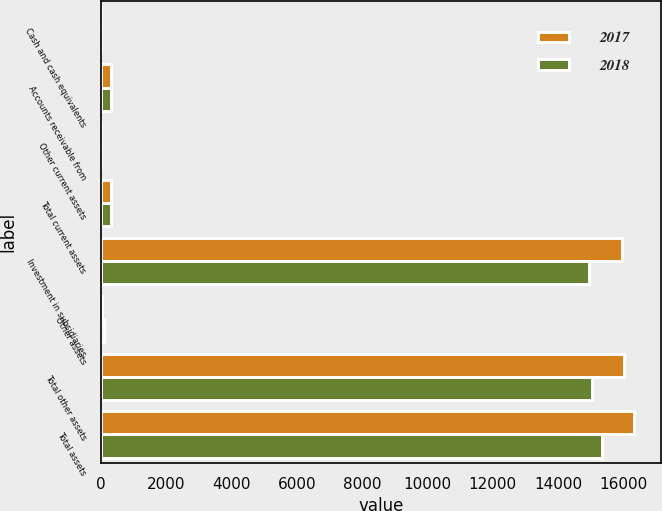<chart> <loc_0><loc_0><loc_500><loc_500><stacked_bar_chart><ecel><fcel>Cash and cash equivalents<fcel>Accounts receivable from<fcel>Other current assets<fcel>Total current assets<fcel>Investment in subsidiaries<fcel>Other assets<fcel>Total other assets<fcel>Total assets<nl><fcel>2017<fcel>1<fcel>309<fcel>1<fcel>311<fcel>15965<fcel>44<fcel>16009<fcel>16320<nl><fcel>2018<fcel>1<fcel>302<fcel>1<fcel>304<fcel>14932<fcel>103<fcel>15035<fcel>15339<nl></chart> 